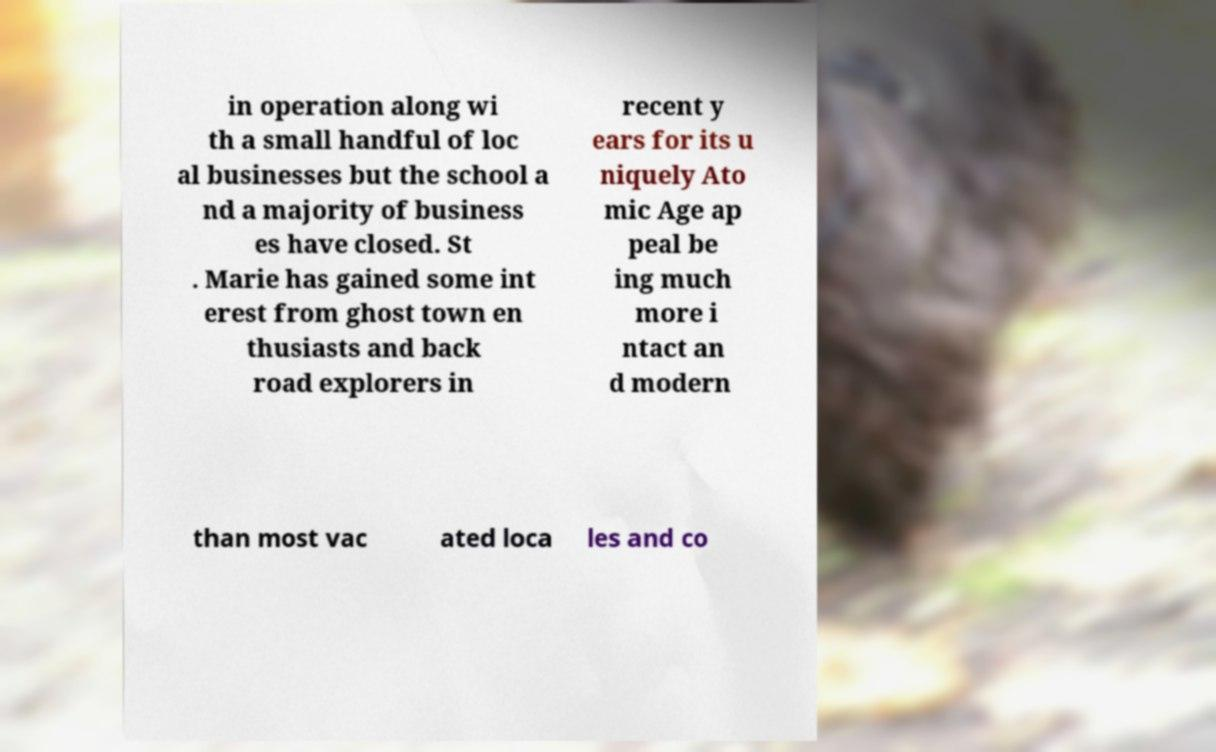I need the written content from this picture converted into text. Can you do that? in operation along wi th a small handful of loc al businesses but the school a nd a majority of business es have closed. St . Marie has gained some int erest from ghost town en thusiasts and back road explorers in recent y ears for its u niquely Ato mic Age ap peal be ing much more i ntact an d modern than most vac ated loca les and co 